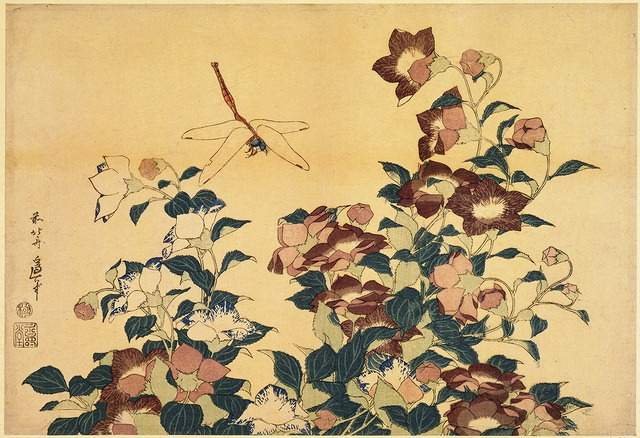What is this photo about? The artwork displayed is a fine example of a Japanese woodblock print, known as ukiyo-e, a form of art that thrived in Japan from the 17th through 19th centuries. This print beautifully showcases a dragonfly in motion over a lush bush, colored predominantly in shades of pink and green against a subtle yellow background. The choice of elements, such as the dragonfly and florals, symbolizes ephemeral beauty—a core theme in much of Japanese art and literature. The inclusion of the artist's signature and seal not only verifies its authenticity but also places the piece within a specific lineage or school of artists. Such prints are often steeped in symbolism and crafted with significant cultural narratives, reflective of the era's aesthetic preferences and philosophical ideologies. 